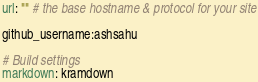<code> <loc_0><loc_0><loc_500><loc_500><_YAML_>url: "" # the base hostname & protocol for your site

github_username:ashsahu

# Build settings
markdown: kramdown
</code> 